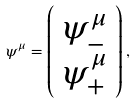Convert formula to latex. <formula><loc_0><loc_0><loc_500><loc_500>\psi ^ { \mu } = \left ( \begin{array} { c } \psi _ { - } ^ { \mu } \\ \psi _ { + } ^ { \mu } \end{array} \right ) ,</formula> 